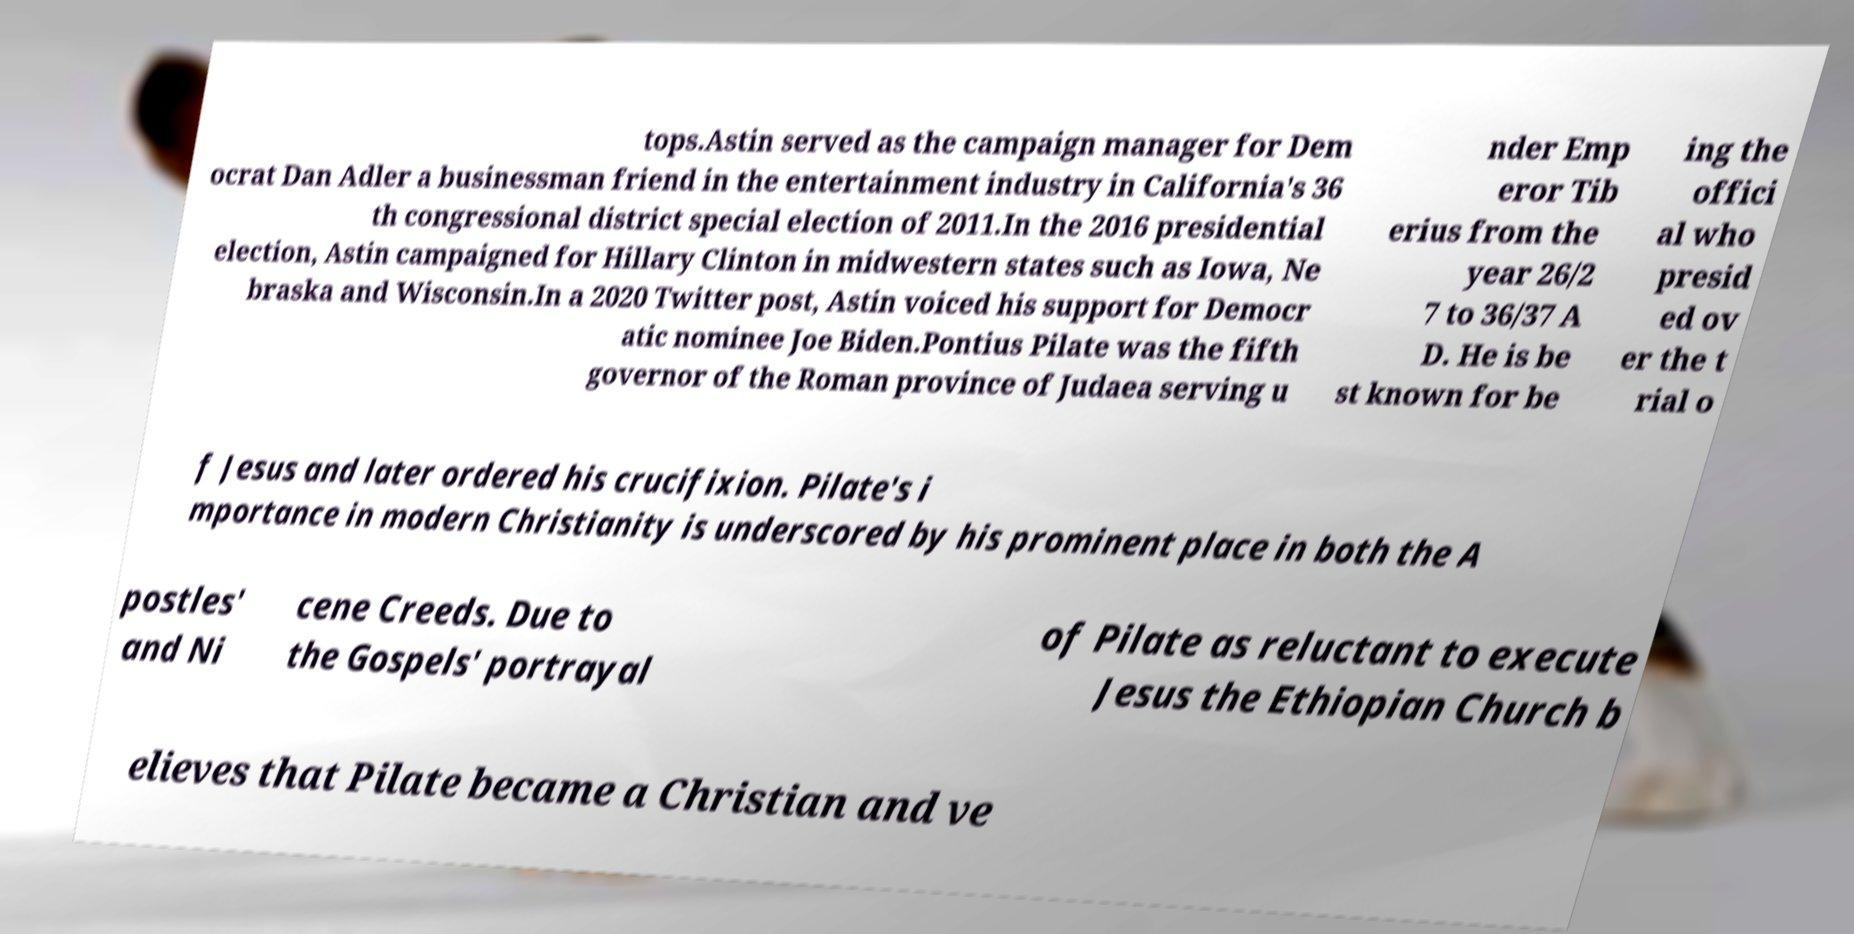What messages or text are displayed in this image? I need them in a readable, typed format. tops.Astin served as the campaign manager for Dem ocrat Dan Adler a businessman friend in the entertainment industry in California's 36 th congressional district special election of 2011.In the 2016 presidential election, Astin campaigned for Hillary Clinton in midwestern states such as Iowa, Ne braska and Wisconsin.In a 2020 Twitter post, Astin voiced his support for Democr atic nominee Joe Biden.Pontius Pilate was the fifth governor of the Roman province of Judaea serving u nder Emp eror Tib erius from the year 26/2 7 to 36/37 A D. He is be st known for be ing the offici al who presid ed ov er the t rial o f Jesus and later ordered his crucifixion. Pilate's i mportance in modern Christianity is underscored by his prominent place in both the A postles' and Ni cene Creeds. Due to the Gospels' portrayal of Pilate as reluctant to execute Jesus the Ethiopian Church b elieves that Pilate became a Christian and ve 